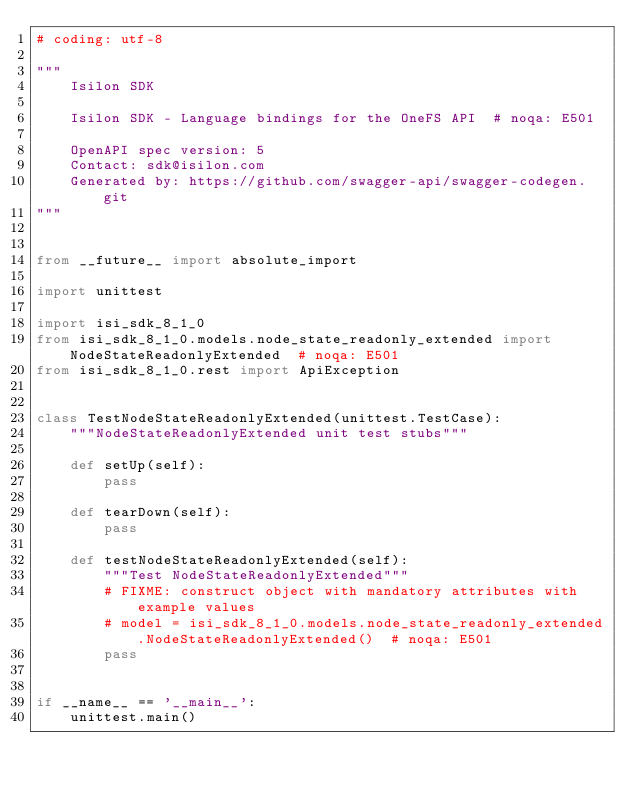Convert code to text. <code><loc_0><loc_0><loc_500><loc_500><_Python_># coding: utf-8

"""
    Isilon SDK

    Isilon SDK - Language bindings for the OneFS API  # noqa: E501

    OpenAPI spec version: 5
    Contact: sdk@isilon.com
    Generated by: https://github.com/swagger-api/swagger-codegen.git
"""


from __future__ import absolute_import

import unittest

import isi_sdk_8_1_0
from isi_sdk_8_1_0.models.node_state_readonly_extended import NodeStateReadonlyExtended  # noqa: E501
from isi_sdk_8_1_0.rest import ApiException


class TestNodeStateReadonlyExtended(unittest.TestCase):
    """NodeStateReadonlyExtended unit test stubs"""

    def setUp(self):
        pass

    def tearDown(self):
        pass

    def testNodeStateReadonlyExtended(self):
        """Test NodeStateReadonlyExtended"""
        # FIXME: construct object with mandatory attributes with example values
        # model = isi_sdk_8_1_0.models.node_state_readonly_extended.NodeStateReadonlyExtended()  # noqa: E501
        pass


if __name__ == '__main__':
    unittest.main()
</code> 